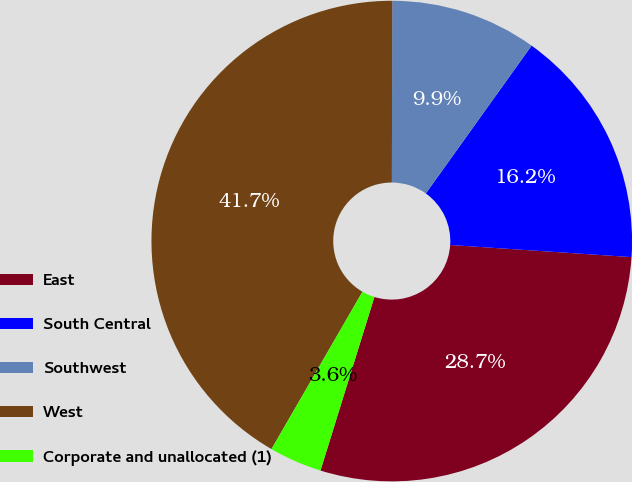Convert chart to OTSL. <chart><loc_0><loc_0><loc_500><loc_500><pie_chart><fcel>East<fcel>South Central<fcel>Southwest<fcel>West<fcel>Corporate and unallocated (1)<nl><fcel>28.73%<fcel>16.18%<fcel>9.85%<fcel>41.69%<fcel>3.55%<nl></chart> 